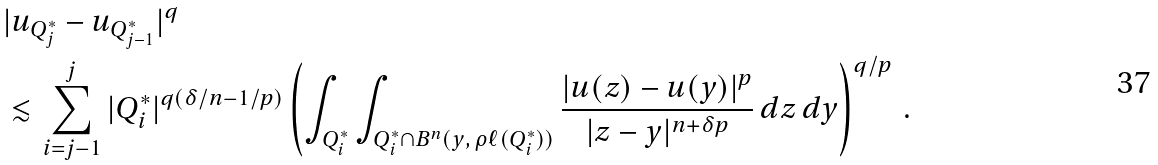<formula> <loc_0><loc_0><loc_500><loc_500>& | u _ { Q ^ { * } _ { j } } - u _ { Q ^ { * } _ { j - 1 } } | ^ { q } \\ & \lesssim \sum _ { i = j - 1 } ^ { j } | Q ^ { * } _ { i } | ^ { q ( \delta / n - 1 / p ) } \left ( \int _ { Q ^ { * } _ { i } } \int _ { Q _ { i } ^ { * } \cap B ^ { n } ( y , \, \rho \ell ( Q _ { i } ^ { * } ) ) } \frac { | u ( z ) - u ( y ) | ^ { p } } { | z - y | ^ { n + \delta p } } \, d z \, d y \right ) ^ { q / p } \, .</formula> 